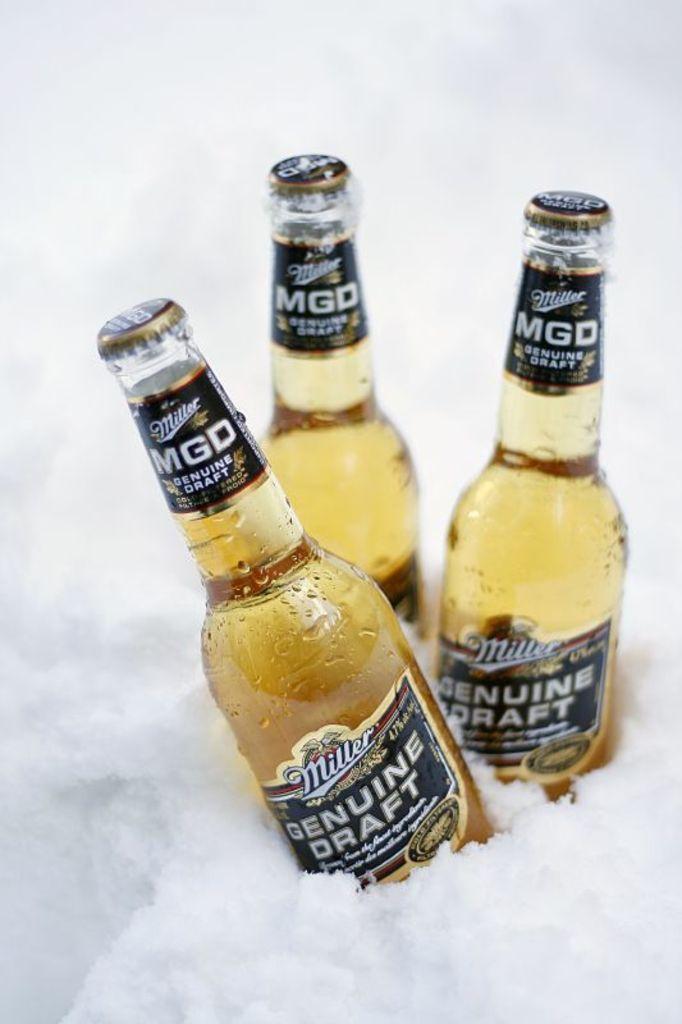Can you describe this image briefly? In the image we can see there are wine bottles in the snow. 